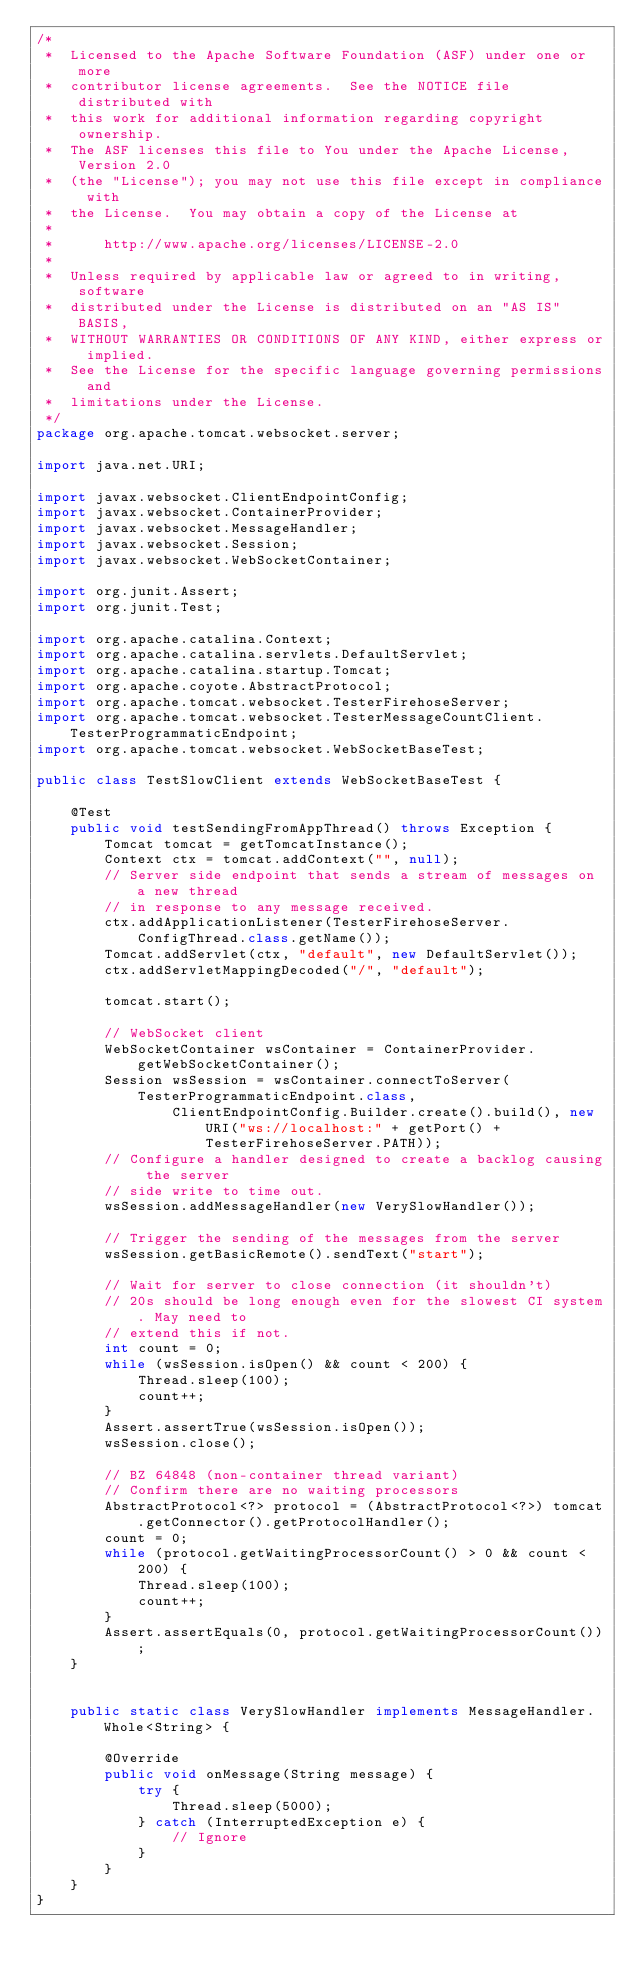<code> <loc_0><loc_0><loc_500><loc_500><_Java_>/*
 *  Licensed to the Apache Software Foundation (ASF) under one or more
 *  contributor license agreements.  See the NOTICE file distributed with
 *  this work for additional information regarding copyright ownership.
 *  The ASF licenses this file to You under the Apache License, Version 2.0
 *  (the "License"); you may not use this file except in compliance with
 *  the License.  You may obtain a copy of the License at
 *
 *      http://www.apache.org/licenses/LICENSE-2.0
 *
 *  Unless required by applicable law or agreed to in writing, software
 *  distributed under the License is distributed on an "AS IS" BASIS,
 *  WITHOUT WARRANTIES OR CONDITIONS OF ANY KIND, either express or implied.
 *  See the License for the specific language governing permissions and
 *  limitations under the License.
 */
package org.apache.tomcat.websocket.server;

import java.net.URI;

import javax.websocket.ClientEndpointConfig;
import javax.websocket.ContainerProvider;
import javax.websocket.MessageHandler;
import javax.websocket.Session;
import javax.websocket.WebSocketContainer;

import org.junit.Assert;
import org.junit.Test;

import org.apache.catalina.Context;
import org.apache.catalina.servlets.DefaultServlet;
import org.apache.catalina.startup.Tomcat;
import org.apache.coyote.AbstractProtocol;
import org.apache.tomcat.websocket.TesterFirehoseServer;
import org.apache.tomcat.websocket.TesterMessageCountClient.TesterProgrammaticEndpoint;
import org.apache.tomcat.websocket.WebSocketBaseTest;

public class TestSlowClient extends WebSocketBaseTest {

    @Test
    public void testSendingFromAppThread() throws Exception {
        Tomcat tomcat = getTomcatInstance();
        Context ctx = tomcat.addContext("", null);
        // Server side endpoint that sends a stream of messages on a new thread
        // in response to any message received.
        ctx.addApplicationListener(TesterFirehoseServer.ConfigThread.class.getName());
        Tomcat.addServlet(ctx, "default", new DefaultServlet());
        ctx.addServletMappingDecoded("/", "default");

        tomcat.start();

        // WebSocket client
        WebSocketContainer wsContainer = ContainerProvider.getWebSocketContainer();
        Session wsSession = wsContainer.connectToServer(TesterProgrammaticEndpoint.class,
                ClientEndpointConfig.Builder.create().build(), new URI("ws://localhost:" + getPort() + TesterFirehoseServer.PATH));
        // Configure a handler designed to create a backlog causing the server
        // side write to time out.
        wsSession.addMessageHandler(new VerySlowHandler());

        // Trigger the sending of the messages from the server
        wsSession.getBasicRemote().sendText("start");

        // Wait for server to close connection (it shouldn't)
        // 20s should be long enough even for the slowest CI system. May need to
        // extend this if not.
        int count = 0;
        while (wsSession.isOpen() && count < 200) {
            Thread.sleep(100);
            count++;
        }
        Assert.assertTrue(wsSession.isOpen());
        wsSession.close();

        // BZ 64848 (non-container thread variant)
        // Confirm there are no waiting processors
        AbstractProtocol<?> protocol = (AbstractProtocol<?>) tomcat.getConnector().getProtocolHandler();
        count = 0;
        while (protocol.getWaitingProcessorCount() > 0 && count < 200) {
            Thread.sleep(100);
            count++;
        }
        Assert.assertEquals(0, protocol.getWaitingProcessorCount());
    }


    public static class VerySlowHandler implements MessageHandler.Whole<String> {

        @Override
        public void onMessage(String message) {
            try {
                Thread.sleep(5000);
            } catch (InterruptedException e) {
                // Ignore
            }
        }
    }
}
</code> 